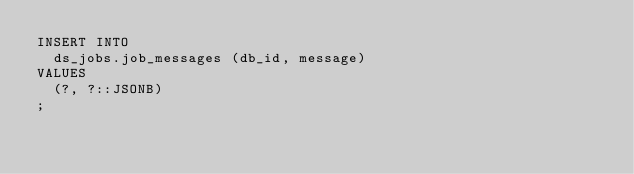<code> <loc_0><loc_0><loc_500><loc_500><_SQL_>INSERT INTO
  ds_jobs.job_messages (db_id, message)
VALUES
  (?, ?::JSONB)
;
</code> 